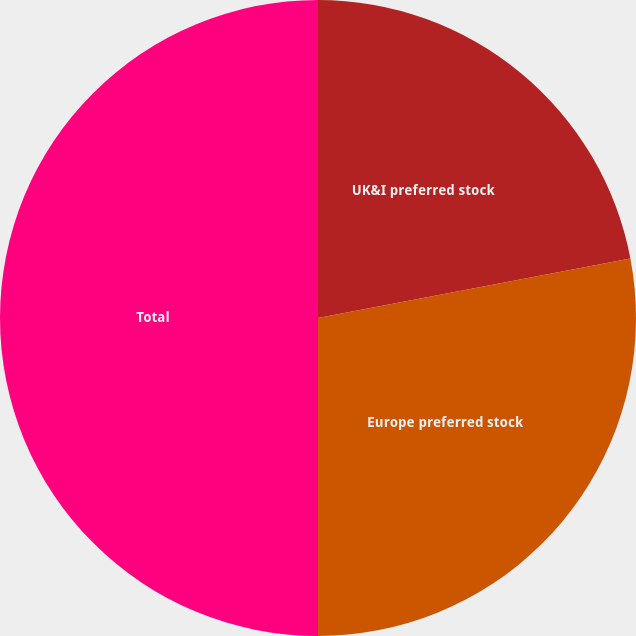<chart> <loc_0><loc_0><loc_500><loc_500><pie_chart><fcel>UK&I preferred stock<fcel>Europe preferred stock<fcel>Total<nl><fcel>22.0%<fcel>28.0%<fcel>50.0%<nl></chart> 